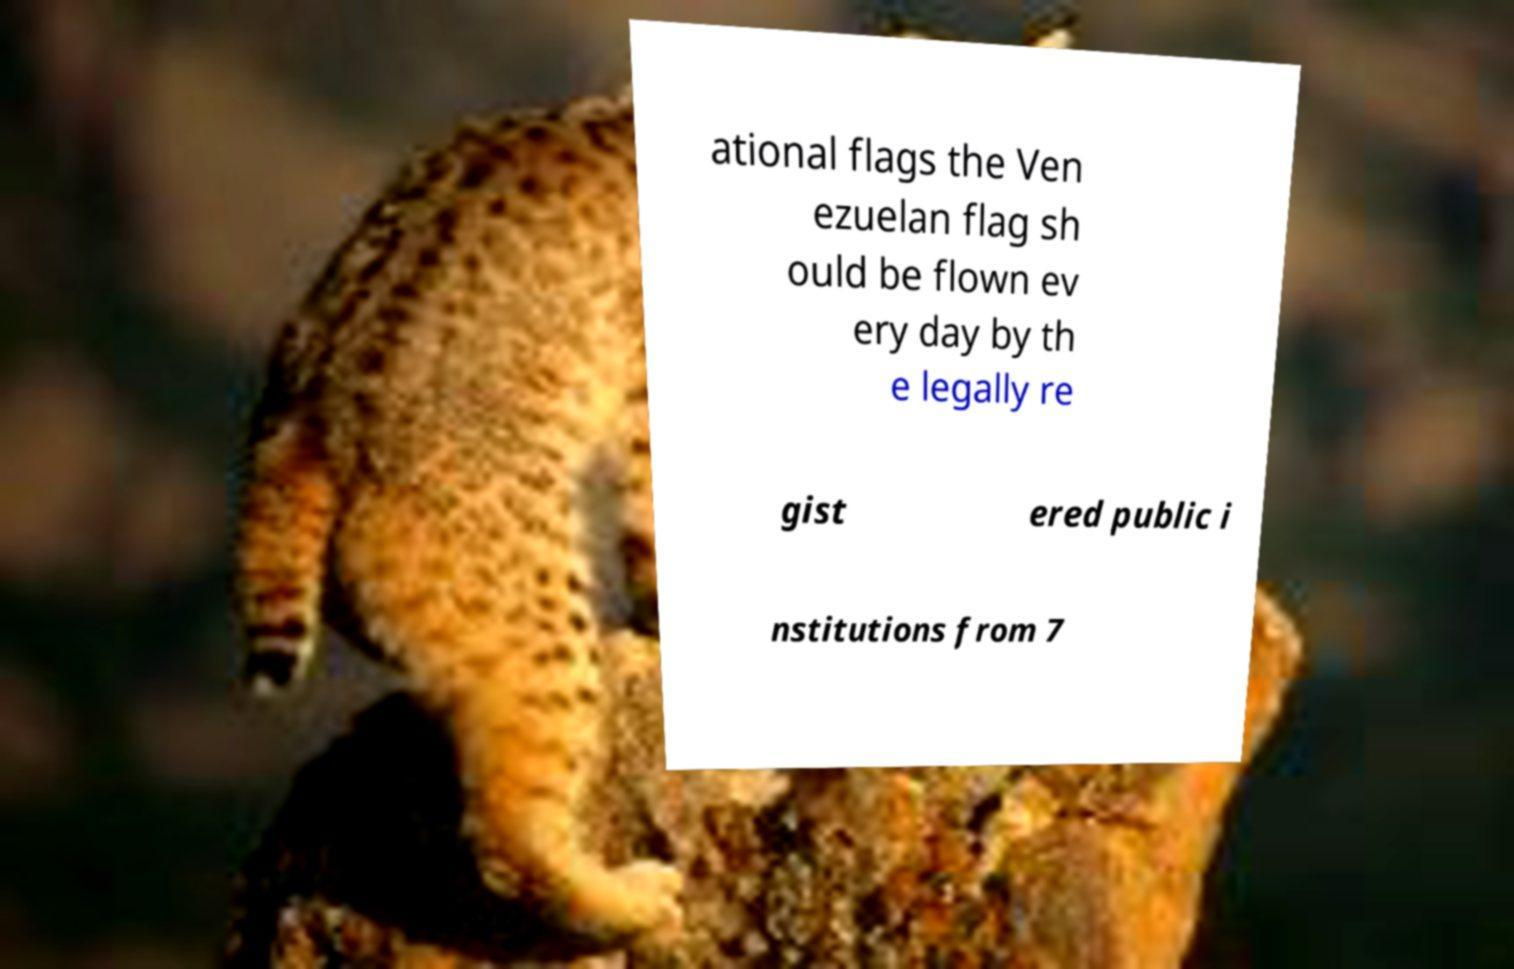There's text embedded in this image that I need extracted. Can you transcribe it verbatim? ational flags the Ven ezuelan flag sh ould be flown ev ery day by th e legally re gist ered public i nstitutions from 7 